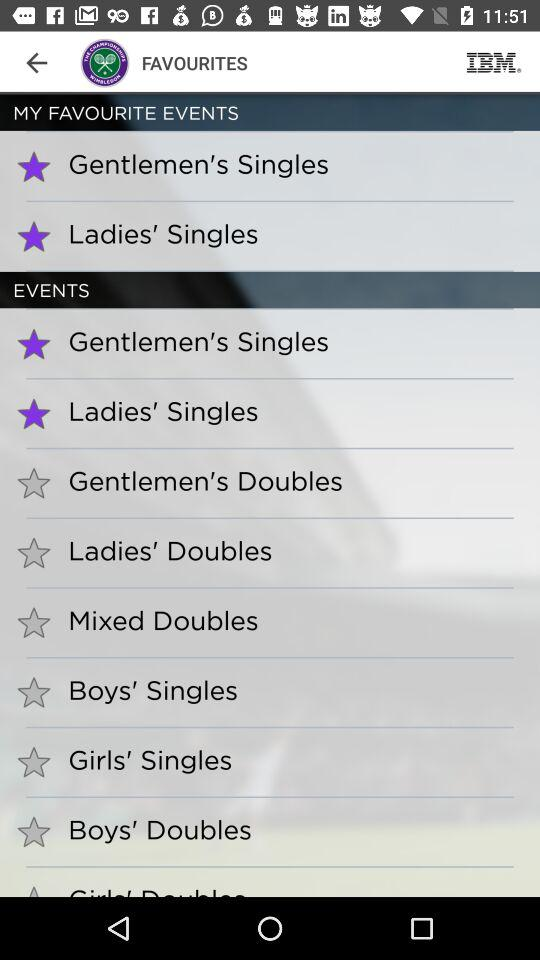Which events are selected? The selected events are "Gentlemen's Singles" and "Ladies' Singles". 